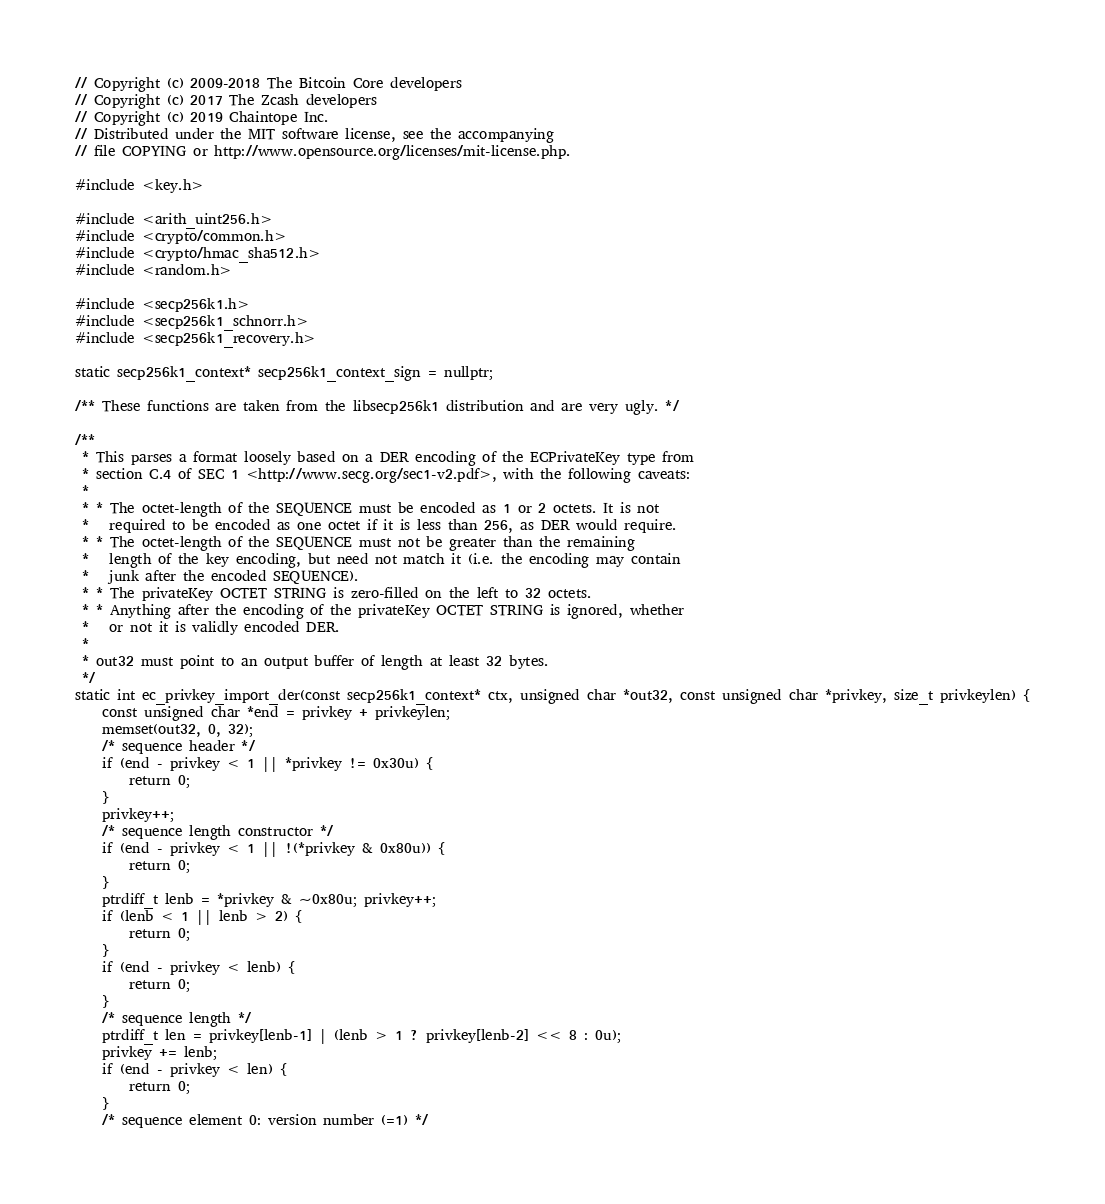<code> <loc_0><loc_0><loc_500><loc_500><_C++_>// Copyright (c) 2009-2018 The Bitcoin Core developers
// Copyright (c) 2017 The Zcash developers
// Copyright (c) 2019 Chaintope Inc.
// Distributed under the MIT software license, see the accompanying
// file COPYING or http://www.opensource.org/licenses/mit-license.php.

#include <key.h>

#include <arith_uint256.h>
#include <crypto/common.h>
#include <crypto/hmac_sha512.h>
#include <random.h>

#include <secp256k1.h>
#include <secp256k1_schnorr.h>
#include <secp256k1_recovery.h>

static secp256k1_context* secp256k1_context_sign = nullptr;

/** These functions are taken from the libsecp256k1 distribution and are very ugly. */

/**
 * This parses a format loosely based on a DER encoding of the ECPrivateKey type from
 * section C.4 of SEC 1 <http://www.secg.org/sec1-v2.pdf>, with the following caveats:
 *
 * * The octet-length of the SEQUENCE must be encoded as 1 or 2 octets. It is not
 *   required to be encoded as one octet if it is less than 256, as DER would require.
 * * The octet-length of the SEQUENCE must not be greater than the remaining
 *   length of the key encoding, but need not match it (i.e. the encoding may contain
 *   junk after the encoded SEQUENCE).
 * * The privateKey OCTET STRING is zero-filled on the left to 32 octets.
 * * Anything after the encoding of the privateKey OCTET STRING is ignored, whether
 *   or not it is validly encoded DER.
 *
 * out32 must point to an output buffer of length at least 32 bytes.
 */
static int ec_privkey_import_der(const secp256k1_context* ctx, unsigned char *out32, const unsigned char *privkey, size_t privkeylen) {
    const unsigned char *end = privkey + privkeylen;
    memset(out32, 0, 32);
    /* sequence header */
    if (end - privkey < 1 || *privkey != 0x30u) {
        return 0;
    }
    privkey++;
    /* sequence length constructor */
    if (end - privkey < 1 || !(*privkey & 0x80u)) {
        return 0;
    }
    ptrdiff_t lenb = *privkey & ~0x80u; privkey++;
    if (lenb < 1 || lenb > 2) {
        return 0;
    }
    if (end - privkey < lenb) {
        return 0;
    }
    /* sequence length */
    ptrdiff_t len = privkey[lenb-1] | (lenb > 1 ? privkey[lenb-2] << 8 : 0u);
    privkey += lenb;
    if (end - privkey < len) {
        return 0;
    }
    /* sequence element 0: version number (=1) */</code> 